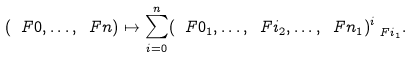Convert formula to latex. <formula><loc_0><loc_0><loc_500><loc_500>( \ F 0 , \dots , \ F n ) \mapsto \sum _ { i = 0 } ^ { n } ( \ F 0 _ { 1 } , \dots , \ F i _ { 2 } , \dots , \ F n _ { 1 } ) ^ { i } _ { \ F i _ { 1 } } .</formula> 